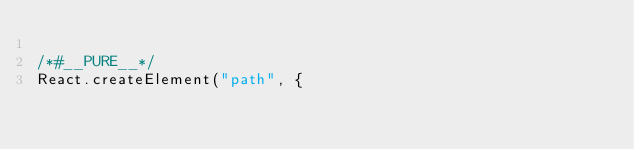Convert code to text. <code><loc_0><loc_0><loc_500><loc_500><_JavaScript_>
/*#__PURE__*/
React.createElement("path", {</code> 